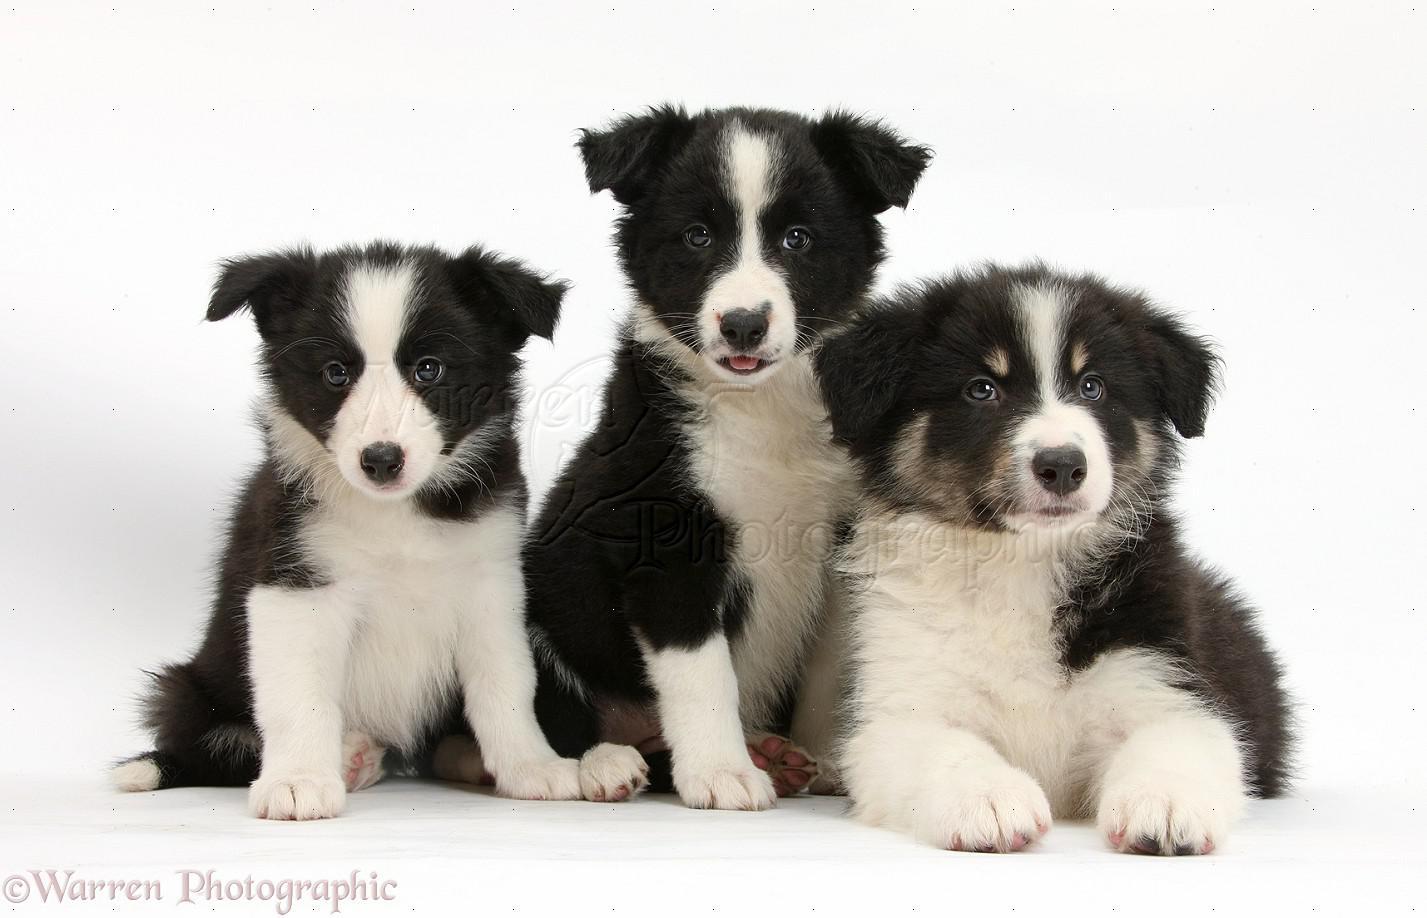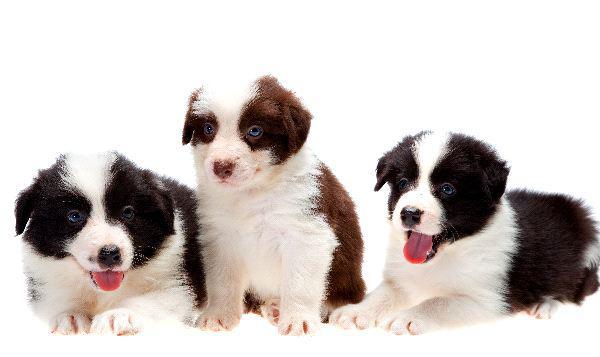The first image is the image on the left, the second image is the image on the right. Examine the images to the left and right. Is the description "No more than four dogs can be seen." accurate? Answer yes or no. No. The first image is the image on the left, the second image is the image on the right. For the images shown, is this caption "Each image contains the same number of puppies, and all images have plain white backgrounds." true? Answer yes or no. Yes. 